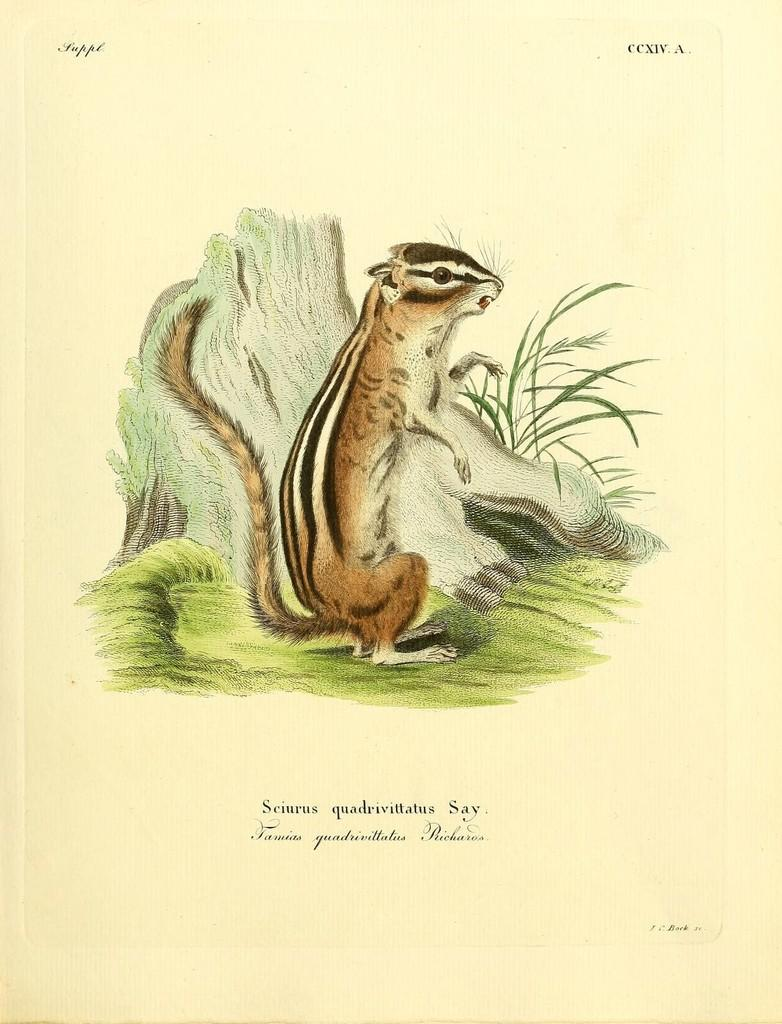What type of image is being described? The image is a poster. What animal is featured in the poster? There is a squirrel in the poster. What is the squirrel standing on? The squirrel is standing on grass. Are there any words or phrases on the poster? Yes, there is text on the poster. What type of silk material is draped over the squirrel in the poster? There is no silk material present in the poster; it features a squirrel standing on grass with text on the poster. How many hearts can be seen in the poster? There are no hearts depicted in the poster. 